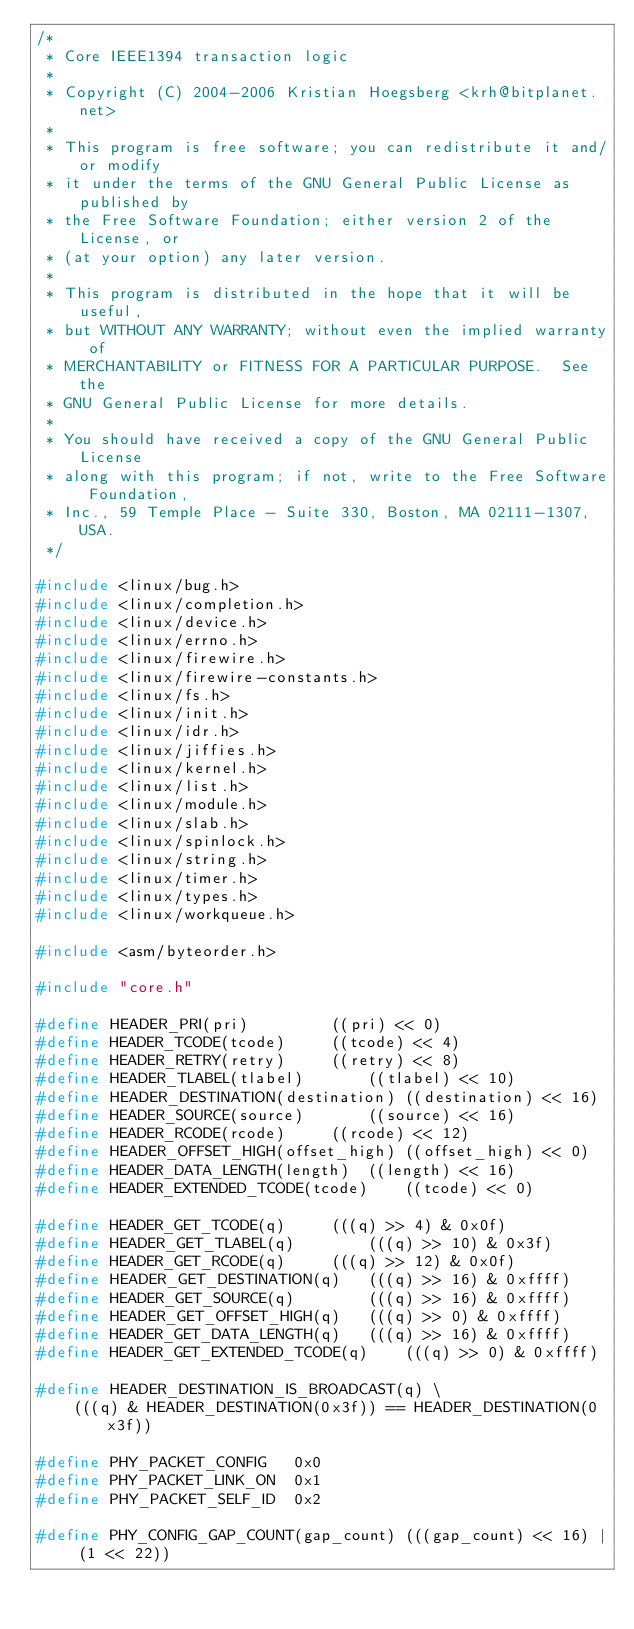Convert code to text. <code><loc_0><loc_0><loc_500><loc_500><_C_>/*
 * Core IEEE1394 transaction logic
 *
 * Copyright (C) 2004-2006 Kristian Hoegsberg <krh@bitplanet.net>
 *
 * This program is free software; you can redistribute it and/or modify
 * it under the terms of the GNU General Public License as published by
 * the Free Software Foundation; either version 2 of the License, or
 * (at your option) any later version.
 *
 * This program is distributed in the hope that it will be useful,
 * but WITHOUT ANY WARRANTY; without even the implied warranty of
 * MERCHANTABILITY or FITNESS FOR A PARTICULAR PURPOSE.  See the
 * GNU General Public License for more details.
 *
 * You should have received a copy of the GNU General Public License
 * along with this program; if not, write to the Free Software Foundation,
 * Inc., 59 Temple Place - Suite 330, Boston, MA 02111-1307, USA.
 */

#include <linux/bug.h>
#include <linux/completion.h>
#include <linux/device.h>
#include <linux/errno.h>
#include <linux/firewire.h>
#include <linux/firewire-constants.h>
#include <linux/fs.h>
#include <linux/init.h>
#include <linux/idr.h>
#include <linux/jiffies.h>
#include <linux/kernel.h>
#include <linux/list.h>
#include <linux/module.h>
#include <linux/slab.h>
#include <linux/spinlock.h>
#include <linux/string.h>
#include <linux/timer.h>
#include <linux/types.h>
#include <linux/workqueue.h>

#include <asm/byteorder.h>

#include "core.h"

#define HEADER_PRI(pri)			((pri) << 0)
#define HEADER_TCODE(tcode)		((tcode) << 4)
#define HEADER_RETRY(retry)		((retry) << 8)
#define HEADER_TLABEL(tlabel)		((tlabel) << 10)
#define HEADER_DESTINATION(destination)	((destination) << 16)
#define HEADER_SOURCE(source)		((source) << 16)
#define HEADER_RCODE(rcode)		((rcode) << 12)
#define HEADER_OFFSET_HIGH(offset_high)	((offset_high) << 0)
#define HEADER_DATA_LENGTH(length)	((length) << 16)
#define HEADER_EXTENDED_TCODE(tcode)	((tcode) << 0)

#define HEADER_GET_TCODE(q)		(((q) >> 4) & 0x0f)
#define HEADER_GET_TLABEL(q)		(((q) >> 10) & 0x3f)
#define HEADER_GET_RCODE(q)		(((q) >> 12) & 0x0f)
#define HEADER_GET_DESTINATION(q)	(((q) >> 16) & 0xffff)
#define HEADER_GET_SOURCE(q)		(((q) >> 16) & 0xffff)
#define HEADER_GET_OFFSET_HIGH(q)	(((q) >> 0) & 0xffff)
#define HEADER_GET_DATA_LENGTH(q)	(((q) >> 16) & 0xffff)
#define HEADER_GET_EXTENDED_TCODE(q)	(((q) >> 0) & 0xffff)

#define HEADER_DESTINATION_IS_BROADCAST(q) \
	(((q) & HEADER_DESTINATION(0x3f)) == HEADER_DESTINATION(0x3f))

#define PHY_PACKET_CONFIG	0x0
#define PHY_PACKET_LINK_ON	0x1
#define PHY_PACKET_SELF_ID	0x2

#define PHY_CONFIG_GAP_COUNT(gap_count)	(((gap_count) << 16) | (1 << 22))</code> 